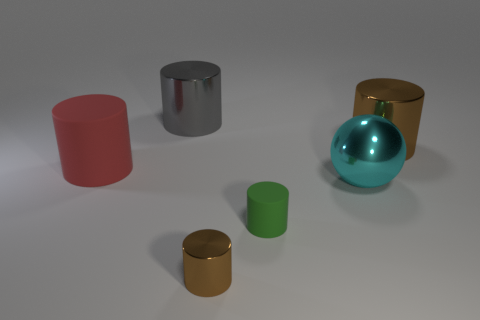Subtract 1 cylinders. How many cylinders are left? 4 Subtract all gray cylinders. How many cylinders are left? 4 Subtract all brown cylinders. How many cylinders are left? 3 Add 3 cyan shiny spheres. How many objects exist? 9 Subtract all green cylinders. Subtract all purple spheres. How many cylinders are left? 4 Subtract all spheres. How many objects are left? 5 Add 2 large gray metal blocks. How many large gray metal blocks exist? 2 Subtract 0 yellow cylinders. How many objects are left? 6 Subtract all large red rubber cylinders. Subtract all green objects. How many objects are left? 4 Add 5 metal objects. How many metal objects are left? 9 